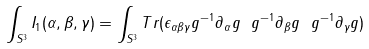Convert formula to latex. <formula><loc_0><loc_0><loc_500><loc_500>\int _ { S ^ { 3 } } { I _ { 1 } ( \alpha , \beta , \gamma ) } = \int _ { S ^ { 3 } } { T r ( \epsilon _ { \alpha \beta \gamma } g ^ { - 1 } \partial _ { \alpha } g \ g ^ { - 1 } \partial _ { \beta } g \ g ^ { - 1 } \partial _ { \gamma } g ) }</formula> 